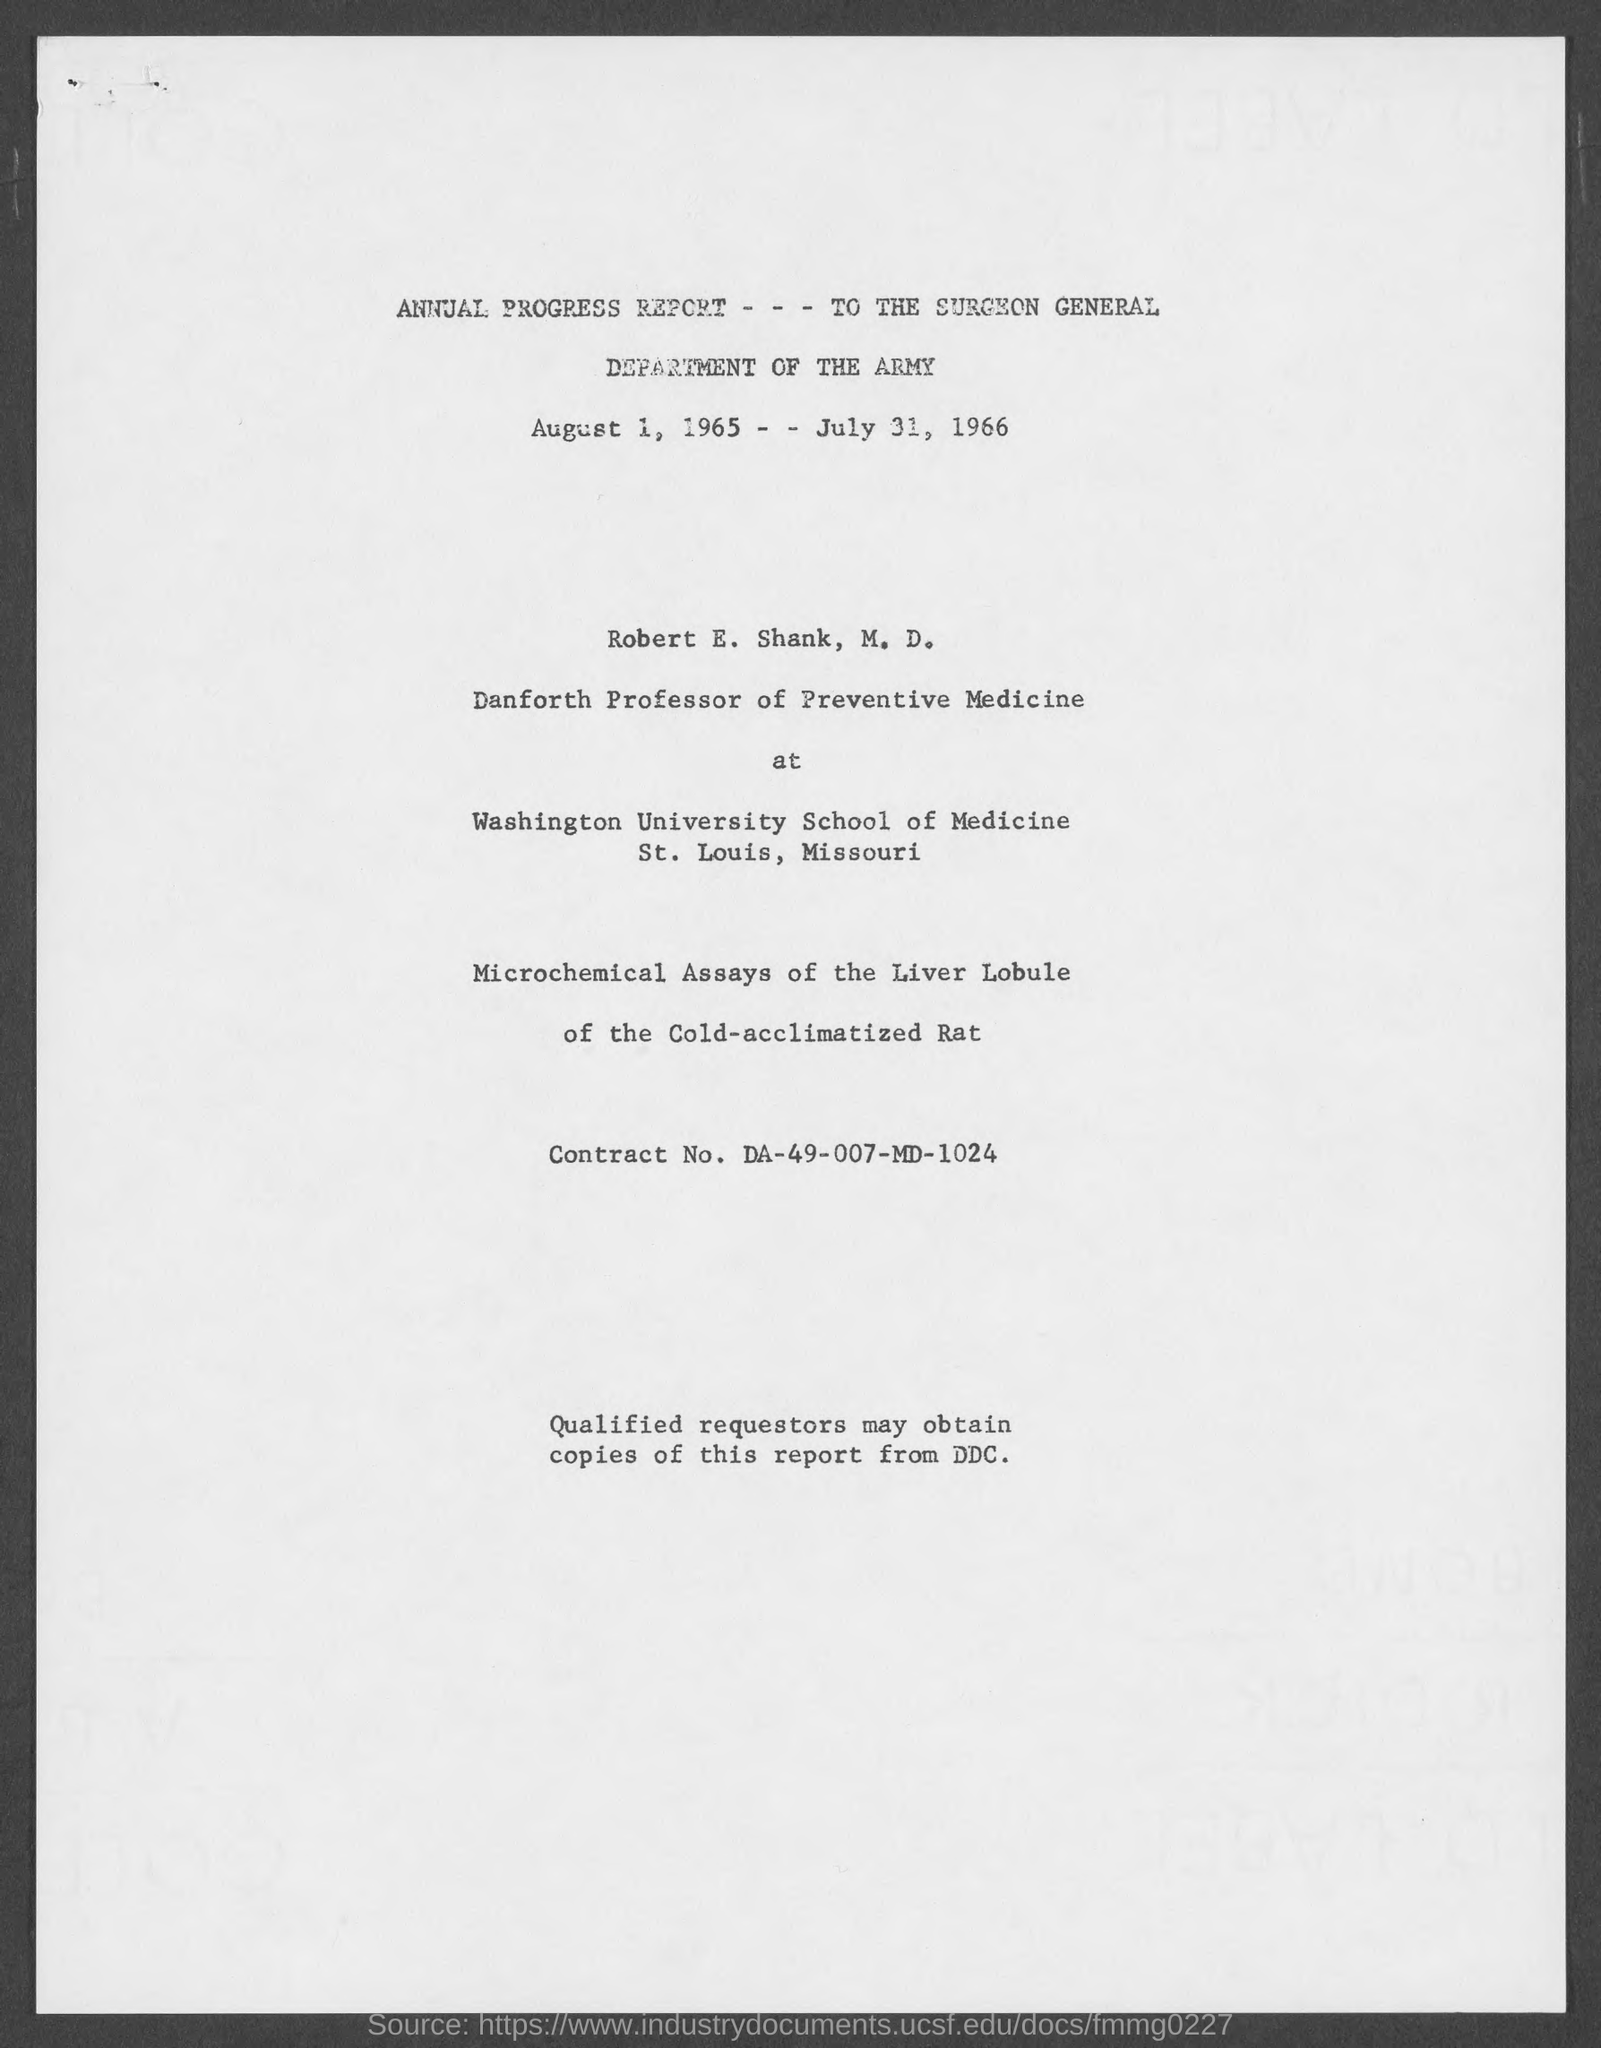Identify some key points in this picture. It is known that Robert E. Shank, M.D., is the Danforth Professor of Preventive Medicine at the Washington School of Medicine. The annual progress report for the year 1966 is presented, with the time period being August 1, 1965, to July 31, 1966. 